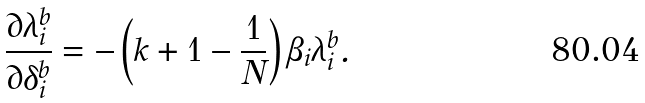Convert formula to latex. <formula><loc_0><loc_0><loc_500><loc_500>\frac { \partial \lambda _ { i } ^ { b } } { \partial \delta _ { i } ^ { b } } = - \left ( k + 1 - \frac { 1 } { N } \right ) \beta _ { i } \lambda _ { i } ^ { b } .</formula> 